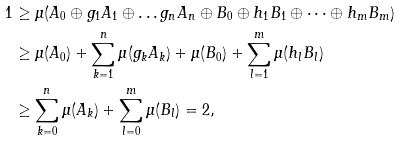<formula> <loc_0><loc_0><loc_500><loc_500>1 & \geq \mu ( A _ { 0 } \oplus g _ { 1 } A _ { 1 } \oplus \dots g _ { n } A _ { n } \oplus B _ { 0 } \oplus h _ { 1 } B _ { 1 } \oplus \dots \oplus h _ { m } B _ { m } ) \\ & \geq \mu ( A _ { 0 } ) + \sum _ { k = 1 } ^ { n } \mu ( g _ { k } A _ { k } ) + \mu ( B _ { 0 } ) + \sum _ { l = 1 } ^ { m } \mu ( h _ { l } B _ { l } ) \\ & \geq \sum _ { k = 0 } ^ { n } \mu ( A _ { k } ) + \sum _ { l = 0 } ^ { m } \mu ( B _ { l } ) = 2 ,</formula> 